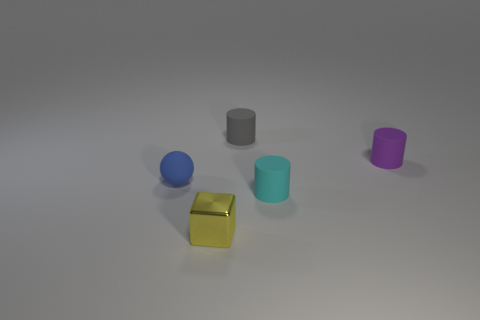Add 3 gray rubber cylinders. How many objects exist? 8 Subtract all cylinders. How many objects are left? 2 Add 3 small yellow metallic blocks. How many small yellow metallic blocks are left? 4 Add 5 large cyan metal spheres. How many large cyan metal spheres exist? 5 Subtract 0 blue blocks. How many objects are left? 5 Subtract all tiny metallic objects. Subtract all blue cylinders. How many objects are left? 4 